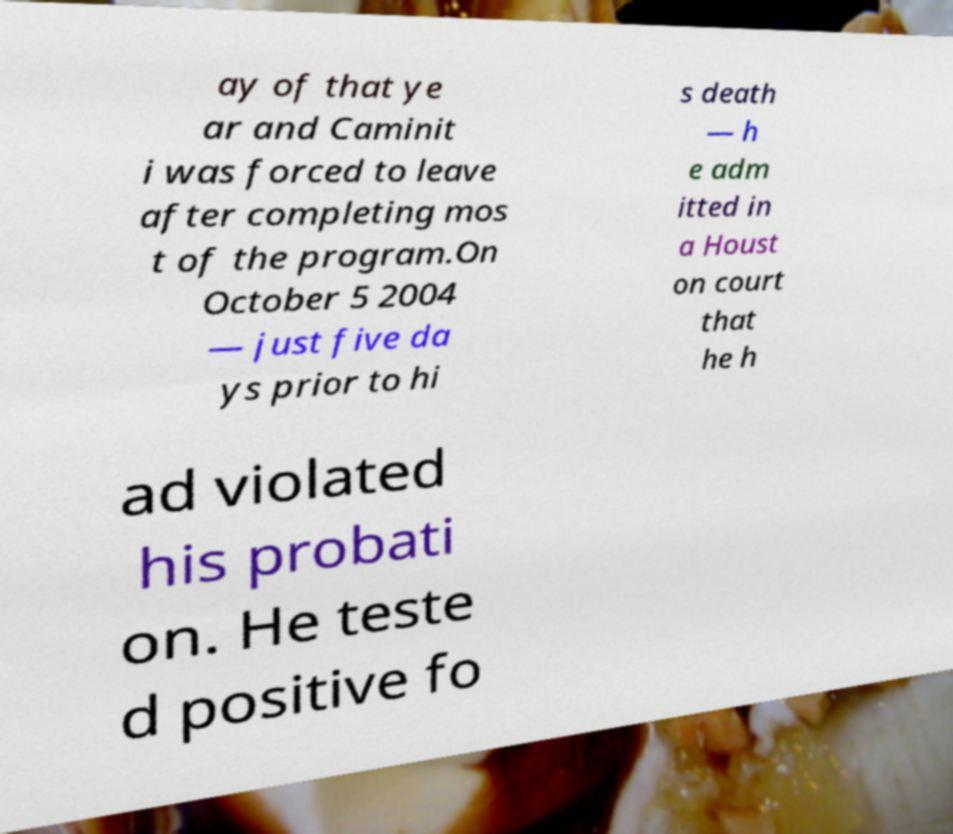Can you read and provide the text displayed in the image?This photo seems to have some interesting text. Can you extract and type it out for me? ay of that ye ar and Caminit i was forced to leave after completing mos t of the program.On October 5 2004 — just five da ys prior to hi s death — h e adm itted in a Houst on court that he h ad violated his probati on. He teste d positive fo 